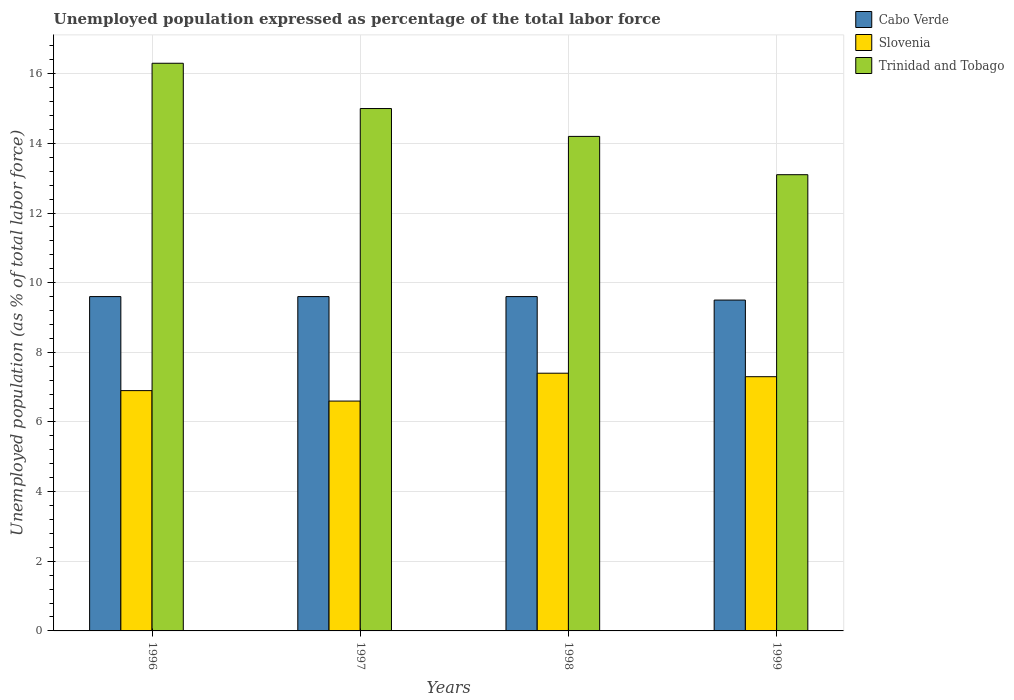Are the number of bars on each tick of the X-axis equal?
Keep it short and to the point. Yes. How many bars are there on the 4th tick from the left?
Your answer should be compact. 3. What is the label of the 4th group of bars from the left?
Offer a very short reply. 1999. What is the unemployment in in Slovenia in 1998?
Provide a short and direct response. 7.4. Across all years, what is the maximum unemployment in in Slovenia?
Give a very brief answer. 7.4. Across all years, what is the minimum unemployment in in Slovenia?
Offer a terse response. 6.6. In which year was the unemployment in in Cabo Verde minimum?
Keep it short and to the point. 1999. What is the total unemployment in in Trinidad and Tobago in the graph?
Provide a succinct answer. 58.6. What is the difference between the unemployment in in Trinidad and Tobago in 1996 and that in 1997?
Offer a terse response. 1.3. What is the difference between the unemployment in in Slovenia in 1997 and the unemployment in in Cabo Verde in 1998?
Make the answer very short. -3. What is the average unemployment in in Cabo Verde per year?
Ensure brevity in your answer.  9.58. In the year 1996, what is the difference between the unemployment in in Cabo Verde and unemployment in in Trinidad and Tobago?
Ensure brevity in your answer.  -6.7. What is the ratio of the unemployment in in Trinidad and Tobago in 1997 to that in 1999?
Keep it short and to the point. 1.15. Is the difference between the unemployment in in Cabo Verde in 1997 and 1999 greater than the difference between the unemployment in in Trinidad and Tobago in 1997 and 1999?
Your response must be concise. No. What is the difference between the highest and the second highest unemployment in in Slovenia?
Provide a succinct answer. 0.1. What is the difference between the highest and the lowest unemployment in in Trinidad and Tobago?
Provide a succinct answer. 3.2. In how many years, is the unemployment in in Slovenia greater than the average unemployment in in Slovenia taken over all years?
Provide a short and direct response. 2. What does the 3rd bar from the left in 1996 represents?
Provide a short and direct response. Trinidad and Tobago. What does the 2nd bar from the right in 1997 represents?
Ensure brevity in your answer.  Slovenia. Is it the case that in every year, the sum of the unemployment in in Cabo Verde and unemployment in in Trinidad and Tobago is greater than the unemployment in in Slovenia?
Offer a very short reply. Yes. How many bars are there?
Offer a terse response. 12. Are all the bars in the graph horizontal?
Provide a succinct answer. No. Are the values on the major ticks of Y-axis written in scientific E-notation?
Offer a very short reply. No. Does the graph contain any zero values?
Your answer should be compact. No. Does the graph contain grids?
Your response must be concise. Yes. Where does the legend appear in the graph?
Keep it short and to the point. Top right. How many legend labels are there?
Provide a short and direct response. 3. What is the title of the graph?
Keep it short and to the point. Unemployed population expressed as percentage of the total labor force. What is the label or title of the Y-axis?
Ensure brevity in your answer.  Unemployed population (as % of total labor force). What is the Unemployed population (as % of total labor force) in Cabo Verde in 1996?
Offer a very short reply. 9.6. What is the Unemployed population (as % of total labor force) of Slovenia in 1996?
Provide a succinct answer. 6.9. What is the Unemployed population (as % of total labor force) in Trinidad and Tobago in 1996?
Make the answer very short. 16.3. What is the Unemployed population (as % of total labor force) in Cabo Verde in 1997?
Your answer should be compact. 9.6. What is the Unemployed population (as % of total labor force) of Slovenia in 1997?
Your answer should be compact. 6.6. What is the Unemployed population (as % of total labor force) in Cabo Verde in 1998?
Keep it short and to the point. 9.6. What is the Unemployed population (as % of total labor force) in Slovenia in 1998?
Your answer should be very brief. 7.4. What is the Unemployed population (as % of total labor force) of Trinidad and Tobago in 1998?
Offer a very short reply. 14.2. What is the Unemployed population (as % of total labor force) in Cabo Verde in 1999?
Offer a very short reply. 9.5. What is the Unemployed population (as % of total labor force) of Slovenia in 1999?
Your answer should be very brief. 7.3. What is the Unemployed population (as % of total labor force) in Trinidad and Tobago in 1999?
Your response must be concise. 13.1. Across all years, what is the maximum Unemployed population (as % of total labor force) in Cabo Verde?
Your response must be concise. 9.6. Across all years, what is the maximum Unemployed population (as % of total labor force) of Slovenia?
Your answer should be very brief. 7.4. Across all years, what is the maximum Unemployed population (as % of total labor force) of Trinidad and Tobago?
Give a very brief answer. 16.3. Across all years, what is the minimum Unemployed population (as % of total labor force) in Slovenia?
Ensure brevity in your answer.  6.6. Across all years, what is the minimum Unemployed population (as % of total labor force) of Trinidad and Tobago?
Ensure brevity in your answer.  13.1. What is the total Unemployed population (as % of total labor force) in Cabo Verde in the graph?
Your answer should be compact. 38.3. What is the total Unemployed population (as % of total labor force) of Slovenia in the graph?
Your answer should be compact. 28.2. What is the total Unemployed population (as % of total labor force) in Trinidad and Tobago in the graph?
Keep it short and to the point. 58.6. What is the difference between the Unemployed population (as % of total labor force) in Cabo Verde in 1996 and that in 1997?
Provide a succinct answer. 0. What is the difference between the Unemployed population (as % of total labor force) in Slovenia in 1996 and that in 1999?
Your answer should be compact. -0.4. What is the difference between the Unemployed population (as % of total labor force) of Trinidad and Tobago in 1996 and that in 1999?
Keep it short and to the point. 3.2. What is the difference between the Unemployed population (as % of total labor force) of Slovenia in 1997 and that in 1998?
Provide a succinct answer. -0.8. What is the difference between the Unemployed population (as % of total labor force) in Trinidad and Tobago in 1997 and that in 1998?
Keep it short and to the point. 0.8. What is the difference between the Unemployed population (as % of total labor force) of Cabo Verde in 1997 and that in 1999?
Ensure brevity in your answer.  0.1. What is the difference between the Unemployed population (as % of total labor force) in Trinidad and Tobago in 1997 and that in 1999?
Make the answer very short. 1.9. What is the difference between the Unemployed population (as % of total labor force) of Cabo Verde in 1998 and that in 1999?
Your answer should be compact. 0.1. What is the difference between the Unemployed population (as % of total labor force) of Slovenia in 1998 and that in 1999?
Your answer should be very brief. 0.1. What is the difference between the Unemployed population (as % of total labor force) in Trinidad and Tobago in 1998 and that in 1999?
Offer a terse response. 1.1. What is the difference between the Unemployed population (as % of total labor force) in Cabo Verde in 1996 and the Unemployed population (as % of total labor force) in Slovenia in 1997?
Provide a short and direct response. 3. What is the difference between the Unemployed population (as % of total labor force) in Cabo Verde in 1996 and the Unemployed population (as % of total labor force) in Trinidad and Tobago in 1997?
Ensure brevity in your answer.  -5.4. What is the difference between the Unemployed population (as % of total labor force) in Slovenia in 1996 and the Unemployed population (as % of total labor force) in Trinidad and Tobago in 1997?
Ensure brevity in your answer.  -8.1. What is the difference between the Unemployed population (as % of total labor force) of Cabo Verde in 1996 and the Unemployed population (as % of total labor force) of Trinidad and Tobago in 1998?
Provide a succinct answer. -4.6. What is the difference between the Unemployed population (as % of total labor force) of Slovenia in 1996 and the Unemployed population (as % of total labor force) of Trinidad and Tobago in 1998?
Make the answer very short. -7.3. What is the difference between the Unemployed population (as % of total labor force) of Cabo Verde in 1996 and the Unemployed population (as % of total labor force) of Slovenia in 1999?
Your answer should be very brief. 2.3. What is the difference between the Unemployed population (as % of total labor force) of Slovenia in 1996 and the Unemployed population (as % of total labor force) of Trinidad and Tobago in 1999?
Give a very brief answer. -6.2. What is the difference between the Unemployed population (as % of total labor force) in Slovenia in 1997 and the Unemployed population (as % of total labor force) in Trinidad and Tobago in 1998?
Your answer should be very brief. -7.6. What is the difference between the Unemployed population (as % of total labor force) of Slovenia in 1998 and the Unemployed population (as % of total labor force) of Trinidad and Tobago in 1999?
Your answer should be compact. -5.7. What is the average Unemployed population (as % of total labor force) of Cabo Verde per year?
Keep it short and to the point. 9.57. What is the average Unemployed population (as % of total labor force) of Slovenia per year?
Your answer should be very brief. 7.05. What is the average Unemployed population (as % of total labor force) of Trinidad and Tobago per year?
Provide a short and direct response. 14.65. In the year 1996, what is the difference between the Unemployed population (as % of total labor force) of Cabo Verde and Unemployed population (as % of total labor force) of Trinidad and Tobago?
Your response must be concise. -6.7. In the year 1996, what is the difference between the Unemployed population (as % of total labor force) of Slovenia and Unemployed population (as % of total labor force) of Trinidad and Tobago?
Keep it short and to the point. -9.4. In the year 1997, what is the difference between the Unemployed population (as % of total labor force) in Cabo Verde and Unemployed population (as % of total labor force) in Slovenia?
Your response must be concise. 3. In the year 1998, what is the difference between the Unemployed population (as % of total labor force) in Slovenia and Unemployed population (as % of total labor force) in Trinidad and Tobago?
Your response must be concise. -6.8. In the year 1999, what is the difference between the Unemployed population (as % of total labor force) of Cabo Verde and Unemployed population (as % of total labor force) of Slovenia?
Make the answer very short. 2.2. In the year 1999, what is the difference between the Unemployed population (as % of total labor force) in Cabo Verde and Unemployed population (as % of total labor force) in Trinidad and Tobago?
Provide a succinct answer. -3.6. In the year 1999, what is the difference between the Unemployed population (as % of total labor force) in Slovenia and Unemployed population (as % of total labor force) in Trinidad and Tobago?
Give a very brief answer. -5.8. What is the ratio of the Unemployed population (as % of total labor force) of Slovenia in 1996 to that in 1997?
Make the answer very short. 1.05. What is the ratio of the Unemployed population (as % of total labor force) in Trinidad and Tobago in 1996 to that in 1997?
Offer a very short reply. 1.09. What is the ratio of the Unemployed population (as % of total labor force) in Slovenia in 1996 to that in 1998?
Keep it short and to the point. 0.93. What is the ratio of the Unemployed population (as % of total labor force) in Trinidad and Tobago in 1996 to that in 1998?
Ensure brevity in your answer.  1.15. What is the ratio of the Unemployed population (as % of total labor force) in Cabo Verde in 1996 to that in 1999?
Offer a very short reply. 1.01. What is the ratio of the Unemployed population (as % of total labor force) in Slovenia in 1996 to that in 1999?
Your response must be concise. 0.95. What is the ratio of the Unemployed population (as % of total labor force) in Trinidad and Tobago in 1996 to that in 1999?
Offer a terse response. 1.24. What is the ratio of the Unemployed population (as % of total labor force) of Slovenia in 1997 to that in 1998?
Your response must be concise. 0.89. What is the ratio of the Unemployed population (as % of total labor force) in Trinidad and Tobago in 1997 to that in 1998?
Offer a very short reply. 1.06. What is the ratio of the Unemployed population (as % of total labor force) in Cabo Verde in 1997 to that in 1999?
Keep it short and to the point. 1.01. What is the ratio of the Unemployed population (as % of total labor force) in Slovenia in 1997 to that in 1999?
Your answer should be very brief. 0.9. What is the ratio of the Unemployed population (as % of total labor force) of Trinidad and Tobago in 1997 to that in 1999?
Keep it short and to the point. 1.15. What is the ratio of the Unemployed population (as % of total labor force) of Cabo Verde in 1998 to that in 1999?
Your answer should be compact. 1.01. What is the ratio of the Unemployed population (as % of total labor force) in Slovenia in 1998 to that in 1999?
Make the answer very short. 1.01. What is the ratio of the Unemployed population (as % of total labor force) in Trinidad and Tobago in 1998 to that in 1999?
Your answer should be compact. 1.08. What is the difference between the highest and the second highest Unemployed population (as % of total labor force) of Cabo Verde?
Make the answer very short. 0. What is the difference between the highest and the second highest Unemployed population (as % of total labor force) of Trinidad and Tobago?
Make the answer very short. 1.3. What is the difference between the highest and the lowest Unemployed population (as % of total labor force) of Cabo Verde?
Offer a very short reply. 0.1. What is the difference between the highest and the lowest Unemployed population (as % of total labor force) in Trinidad and Tobago?
Ensure brevity in your answer.  3.2. 